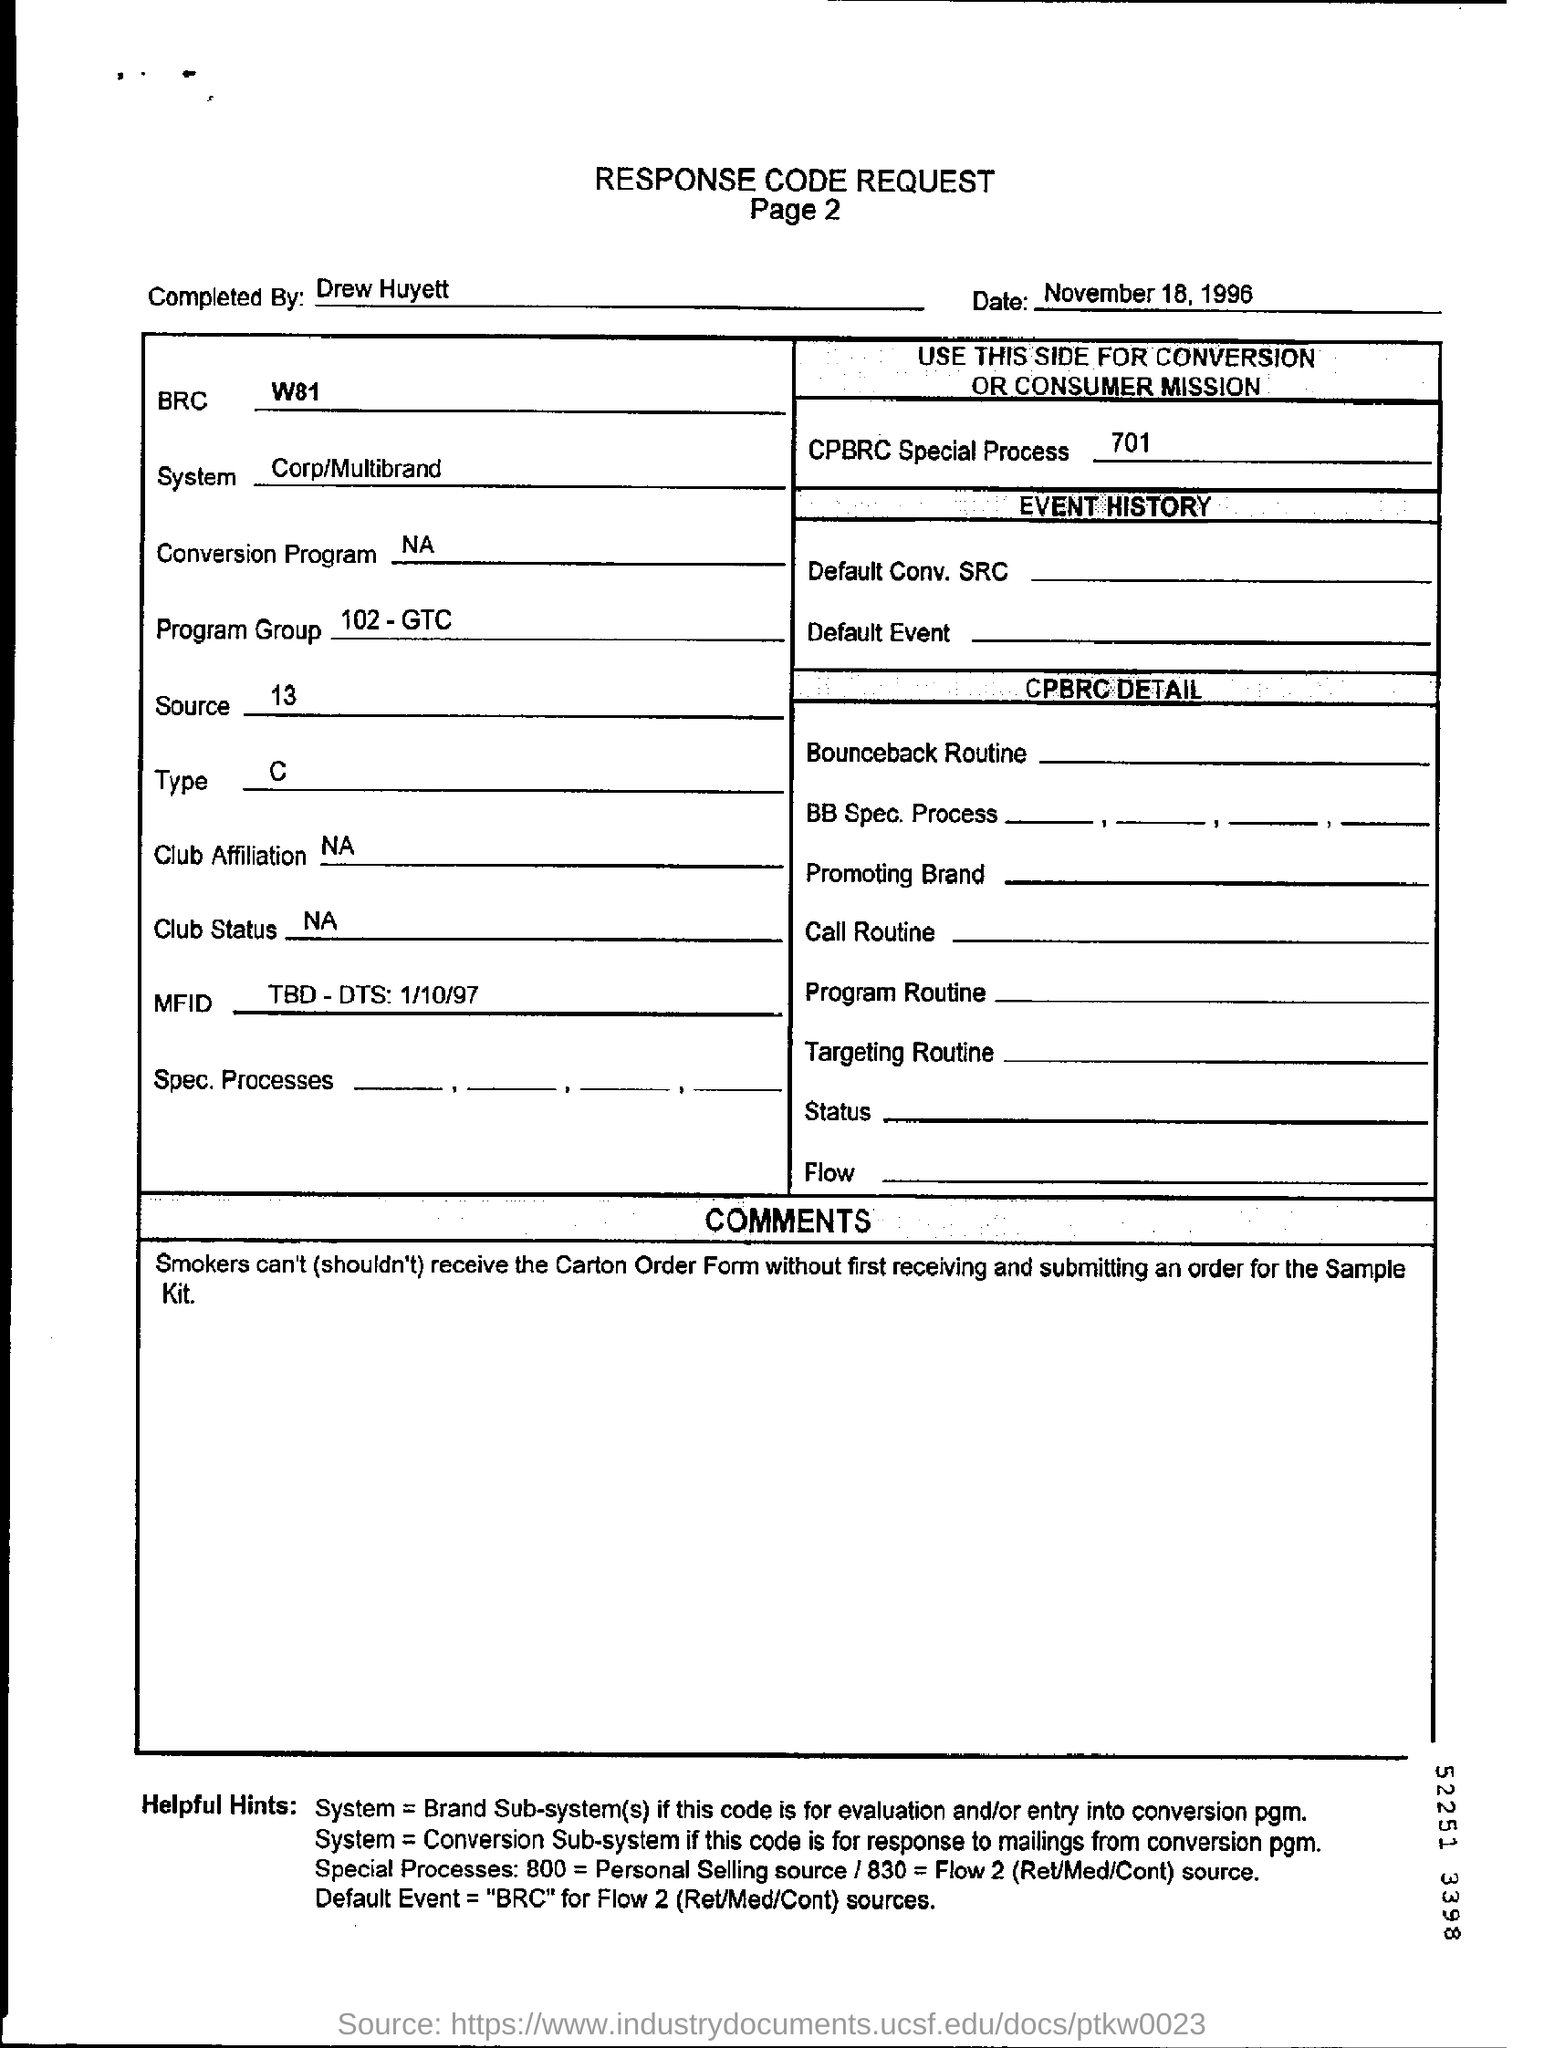Who cant receive the carton order form?
Offer a terse response. Smokers. What is the program group mentioned in the response code request?
Offer a very short reply. 102-GTC. What is the default event sources for flow 2?
Your answer should be compact. "BRC". 